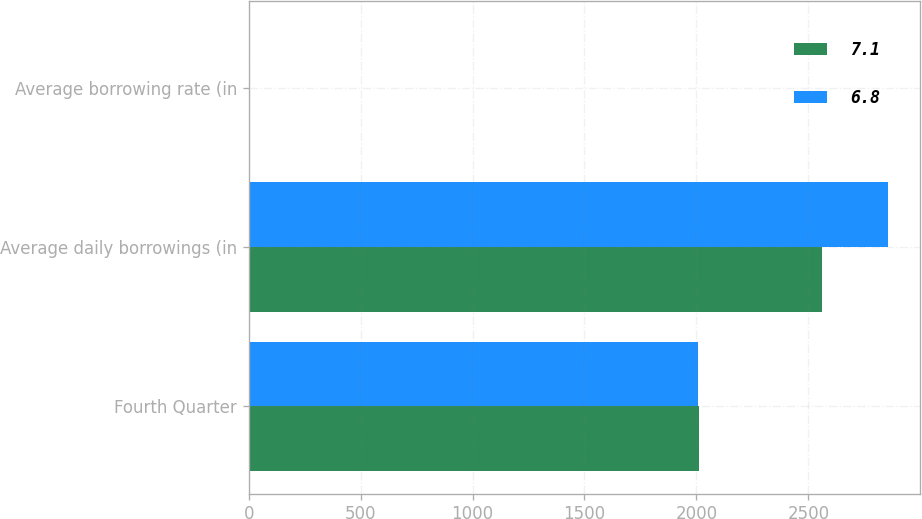Convert chart to OTSL. <chart><loc_0><loc_0><loc_500><loc_500><stacked_bar_chart><ecel><fcel>Fourth Quarter<fcel>Average daily borrowings (in<fcel>Average borrowing rate (in<nl><fcel>7.1<fcel>2010<fcel>2560<fcel>7.1<nl><fcel>6.8<fcel>2009<fcel>2857<fcel>6.8<nl></chart> 